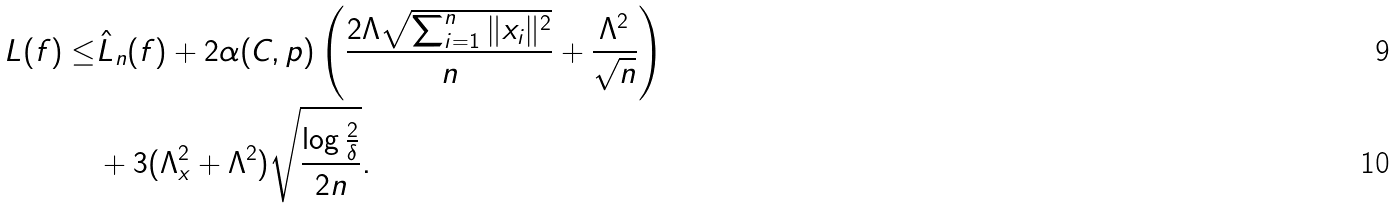Convert formula to latex. <formula><loc_0><loc_0><loc_500><loc_500>L ( f ) \leq & \hat { L } _ { n } ( f ) + 2 \alpha ( C , p ) \left ( \frac { 2 \Lambda \sqrt { \sum _ { i = 1 } ^ { n } \| x _ { i } \| ^ { 2 } } } { n } + \frac { \Lambda ^ { 2 } } { \sqrt { n } } \right ) \\ & + 3 ( \Lambda _ { x } ^ { 2 } + \Lambda ^ { 2 } ) \sqrt { \frac { \log \frac { 2 } { \delta } } { 2 n } } .</formula> 